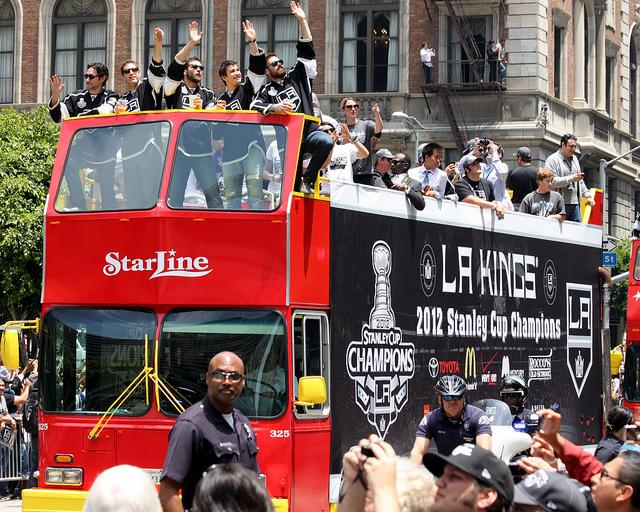What kind of team is this celebrating? hockey 